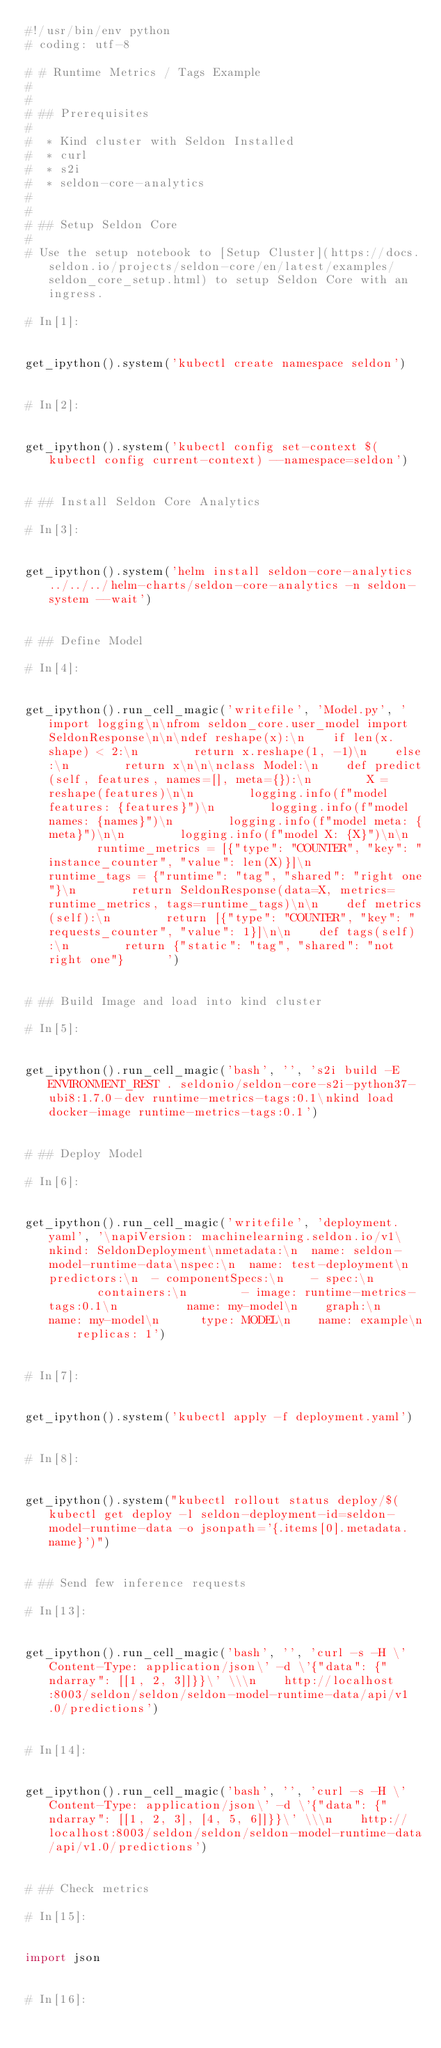<code> <loc_0><loc_0><loc_500><loc_500><_Python_>#!/usr/bin/env python
# coding: utf-8

# # Runtime Metrics / Tags Example
# 
# 
# ## Prerequisites
# 
#  * Kind cluster with Seldon Installed
#  * curl
#  * s2i
#  * seldon-core-analytics
# 
#  
# ## Setup Seldon Core
# 
# Use the setup notebook to [Setup Cluster](https://docs.seldon.io/projects/seldon-core/en/latest/examples/seldon_core_setup.html) to setup Seldon Core with an ingress.

# In[1]:


get_ipython().system('kubectl create namespace seldon')


# In[2]:


get_ipython().system('kubectl config set-context $(kubectl config current-context) --namespace=seldon')


# ## Install Seldon Core Analytics

# In[3]:


get_ipython().system('helm install seldon-core-analytics ../../../helm-charts/seldon-core-analytics -n seldon-system --wait')


# ## Define Model

# In[4]:


get_ipython().run_cell_magic('writefile', 'Model.py', 'import logging\n\nfrom seldon_core.user_model import SeldonResponse\n\n\ndef reshape(x):\n    if len(x.shape) < 2:\n        return x.reshape(1, -1)\n    else:\n        return x\n\n\nclass Model:\n    def predict(self, features, names=[], meta={}):\n        X = reshape(features)\n\n        logging.info(f"model features: {features}")\n        logging.info(f"model names: {names}")\n        logging.info(f"model meta: {meta}")\n\n        logging.info(f"model X: {X}")\n\n        runtime_metrics = [{"type": "COUNTER", "key": "instance_counter", "value": len(X)}]\n        runtime_tags = {"runtime": "tag", "shared": "right one"}\n        return SeldonResponse(data=X, metrics=runtime_metrics, tags=runtime_tags)\n\n    def metrics(self):\n        return [{"type": "COUNTER", "key": "requests_counter", "value": 1}]\n\n    def tags(self):\n        return {"static": "tag", "shared": "not right one"}      ')


# ## Build Image and load into kind cluster

# In[5]:


get_ipython().run_cell_magic('bash', '', 's2i build -E ENVIRONMENT_REST . seldonio/seldon-core-s2i-python37-ubi8:1.7.0-dev runtime-metrics-tags:0.1\nkind load docker-image runtime-metrics-tags:0.1')


# ## Deploy Model

# In[6]:


get_ipython().run_cell_magic('writefile', 'deployment.yaml', '\napiVersion: machinelearning.seldon.io/v1\nkind: SeldonDeployment\nmetadata:\n  name: seldon-model-runtime-data\nspec:\n  name: test-deployment\n  predictors:\n  - componentSpecs:\n    - spec:\n        containers:\n        - image: runtime-metrics-tags:0.1\n          name: my-model\n    graph:\n      name: my-model\n      type: MODEL\n    name: example\n    replicas: 1')


# In[7]:


get_ipython().system('kubectl apply -f deployment.yaml')


# In[8]:


get_ipython().system("kubectl rollout status deploy/$(kubectl get deploy -l seldon-deployment-id=seldon-model-runtime-data -o jsonpath='{.items[0].metadata.name}')")


# ## Send few inference requests

# In[13]:


get_ipython().run_cell_magic('bash', '', 'curl -s -H \'Content-Type: application/json\' -d \'{"data": {"ndarray": [[1, 2, 3]]}}\' \\\n    http://localhost:8003/seldon/seldon/seldon-model-runtime-data/api/v1.0/predictions')


# In[14]:


get_ipython().run_cell_magic('bash', '', 'curl -s -H \'Content-Type: application/json\' -d \'{"data": {"ndarray": [[1, 2, 3], [4, 5, 6]]}}\' \\\n    http://localhost:8003/seldon/seldon/seldon-model-runtime-data/api/v1.0/predictions')


# ## Check metrics

# In[15]:


import json


# In[16]:

</code> 